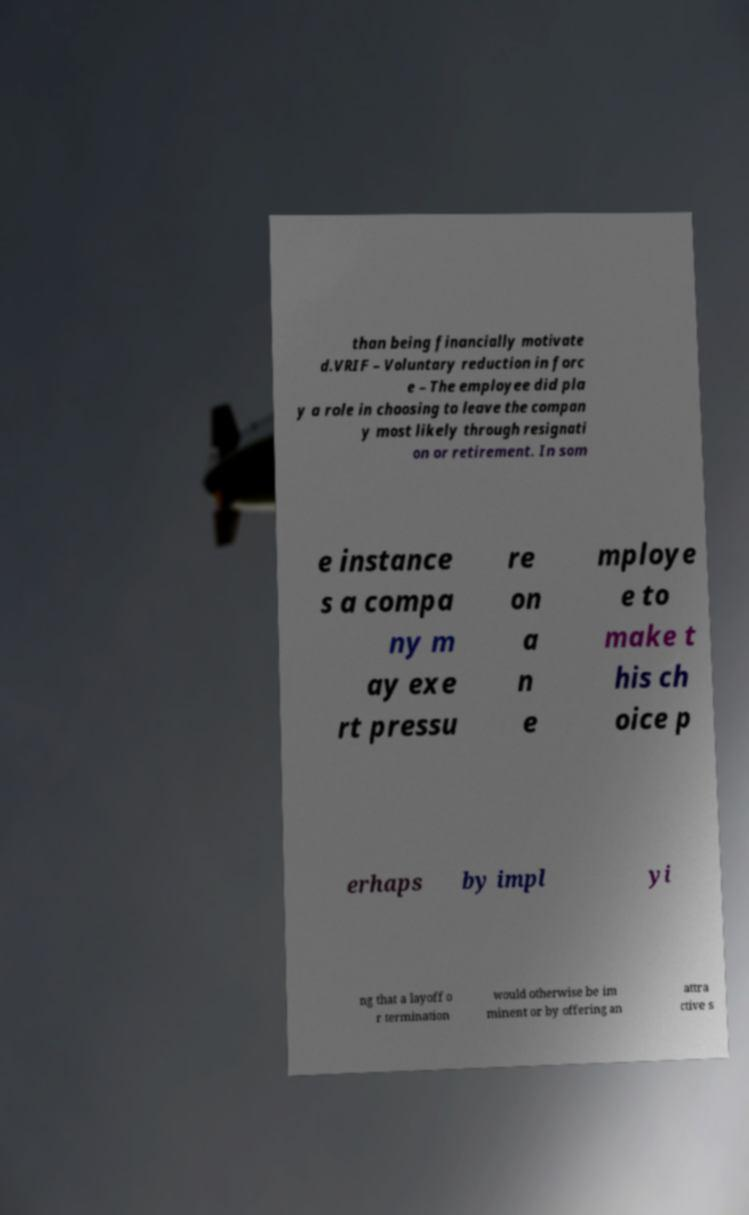Please identify and transcribe the text found in this image. than being financially motivate d.VRIF – Voluntary reduction in forc e – The employee did pla y a role in choosing to leave the compan y most likely through resignati on or retirement. In som e instance s a compa ny m ay exe rt pressu re on a n e mploye e to make t his ch oice p erhaps by impl yi ng that a layoff o r termination would otherwise be im minent or by offering an attra ctive s 